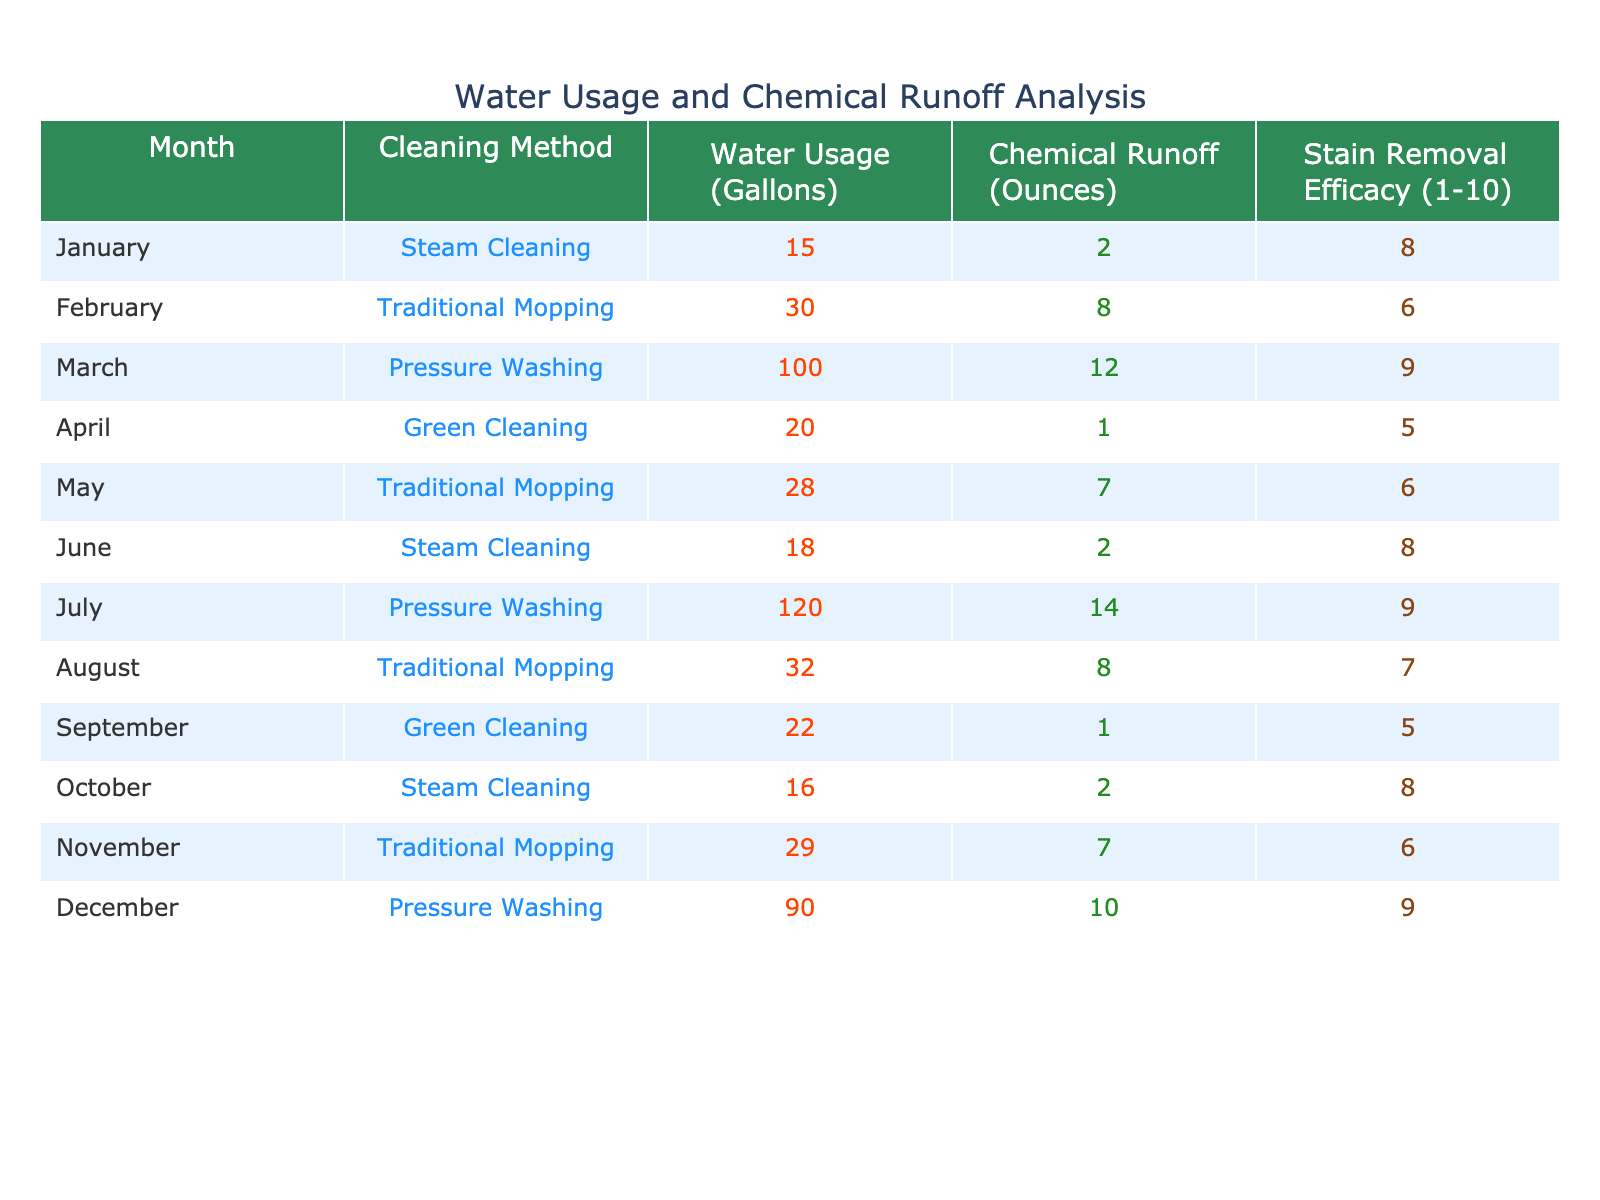What is the water usage for Pressure Washing in July? The table shows the specific water usage for Pressure Washing in July is listed directly. According to the data, it is 120 gallons.
Answer: 120 gallons What month had the highest chemical runoff? By examining the data table, we can see that the month with the highest chemical runoff is July, with 14 ounces from Pressure Washing.
Answer: July What is the average stain removal efficacy for Traditional Mopping? First, we need to identify the stain removal efficacy for each month using Traditional Mopping: (6 + 6 + 7 + 6) = 25. There are 4 instances, so the average efficacy is 25 / 4 = 6.25.
Answer: 6.25 Did Green Cleaning ever use more than 25 gallons of water? Looking through the data, we see that Green Cleaning had a maximum water usage of 22 gallons in September, which is not more than 25 gallons.
Answer: No What was the total water usage for Steam Cleaning throughout the year? To get the total water usage for Steam Cleaning, we sum the values: 15 (Jan) + 18 (Jun) + 16 (Oct) = 49 gallons.
Answer: 49 gallons Is the chemical runoff higher on average for Pressure Washing compared to Traditional Mopping? Calculate the average runoff for both methods: Pressure Washing runoff values are (12 + 14 + 10) = 36 ounces, and there are 3 entries, giving an average of 12 ounces. Traditional Mopping values are (8 + 7 + 8 + 7) = 30 ounces, over 4 months, resulting in an average of 7.5 ounces. Since 12 > 7.5, we conclude that Pressure Washing has higher average runoff.
Answer: Yes What is the difference in water usage between the month with the highest and lowest usage? The highest water usage is 120 gallons in July (Pressure Washing), and the lowest is 15 gallons in January (Steam Cleaning). The difference is 120 - 15 = 105 gallons.
Answer: 105 gallons Which cleaning method had the highest efficacy, and during what month did it occur? The highest efficacy is 9, which occurred in March and July for Pressure Washing.
Answer: Pressure Washing in March and July How much more chemical runoff is there in March compared to April? In March, the chemical runoff is 12 ounces and in April is 1 ounce. The difference is 12 - 1 = 11 ounces.
Answer: 11 ounces Is the stain removal efficacy for Green Cleaning ever above a 6? Checking the efficacy values for Green Cleaning, both instances (April and September) scored 5, which is not above 6.
Answer: No 